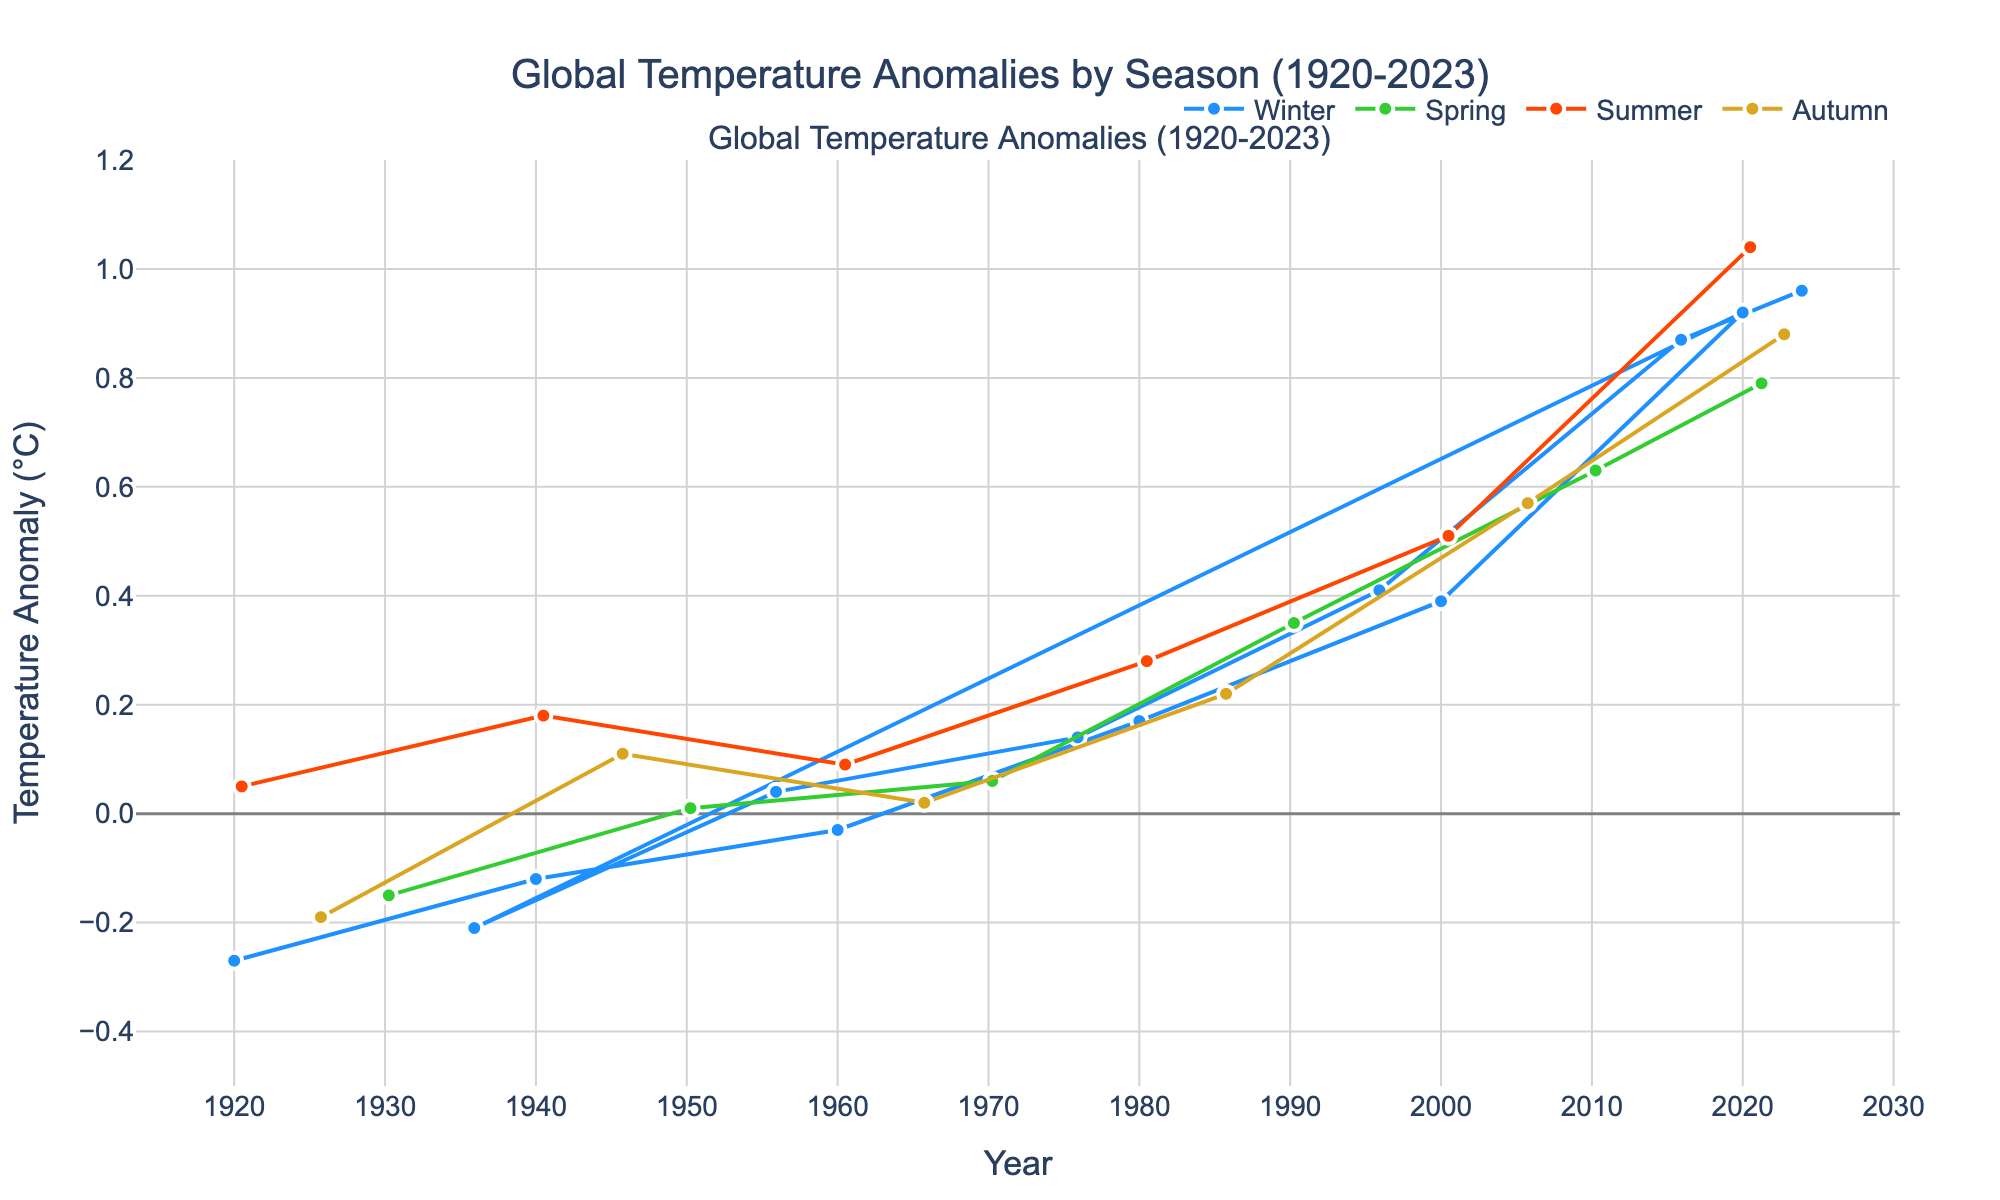What is the highest global temperature anomaly for spring, and in which year did it occur? First, identify the data points for spring, characterized by green lines. Then, find the data point with the highest temperature anomaly among the spring months.
Answer: 2021, 0.79°C Which season shows the greatest increase in temperature anomalies from 1920 to 2020? Compare the change in temperature anomalies for each season from 1920 to 2020. Calculate the difference for Winter (0.92 - (-0.27) = 1.19), Spring (0.63 - (-0.15) = 0.78), Summer (1.04 - 0.05 = 0.99), and Autumn (0.88 - (-0.19) = 1.07).
Answer: Winter Between Winter and Summer of 2000, which season had a higher temperature anomaly, and by how much? Look at the data points for Winter and Summer in the year 2000. Winter anomaly is 0.39°C, and Summer anomaly is 0.51°C. Find the difference (0.51 - 0.39 = 0.12).
Answer: Summer, by 0.12°C What is the average global temperature anomaly for the year 1980 considering all seasons? Collect the temperature anomalies for all seasons in 1980: Winter (0.17), Summer (0.28). Note that only Winter and Summer data points are given. Calculate the average ( (0.17 + 0.28) / 2 = 0.225).
Answer: 0.225°C Compare the temperature anomalies for Winter and Autumn in 1940. Which season has a greater anomaly, and what’s the difference? Identify the data points for Winter and Autumn in 1940. Winter anomaly is -0.12°C and no Autumn data is given for 1940. Hence, Winter anomaly data is given and Autumn not available to compare.
Answer: Winter, Autumn data not available What is the temperature anomaly trend for summer months from 1920 to 2020? Look at the data points for Summer across these years: 1920 (0.05), 1940 (0.18), 1960 (0.09), 1980 (0.28), 2000 (0.51), 2020 (1.04). Notice the increasing trend over time.
Answer: Increasing Does Spring of 1960 have a higher temperature anomaly than Winter of 1960? Check the temperature anomalies for Spring and Winter in 1960. Spring data not given for 1960. Winter anomaly is -0.03°C and no Spring data is given for 1960.
Answer: Winter data available, Spring not available Which decade showed the highest overall global temperature anomaly in Winter? Evaluate the Winter anomalies for each decade: 1920 (-0.27), 1930 (data not available), 1940 (-0.12), 1950 (data not available), 1960 (-0.03), 1970 (data not available), 1980 (0.17), 1990 (data not available for Winter), 2000 (0.39), 2010 (data not available for Winter), 2020 (0.92). The highest is 2020 with 0.92°C.
Answer: 2020s 